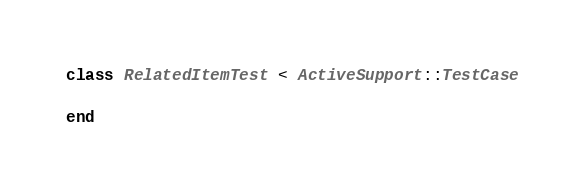Convert code to text. <code><loc_0><loc_0><loc_500><loc_500><_Ruby_>
class RelatedItemTest < ActiveSupport::TestCase

end
</code> 